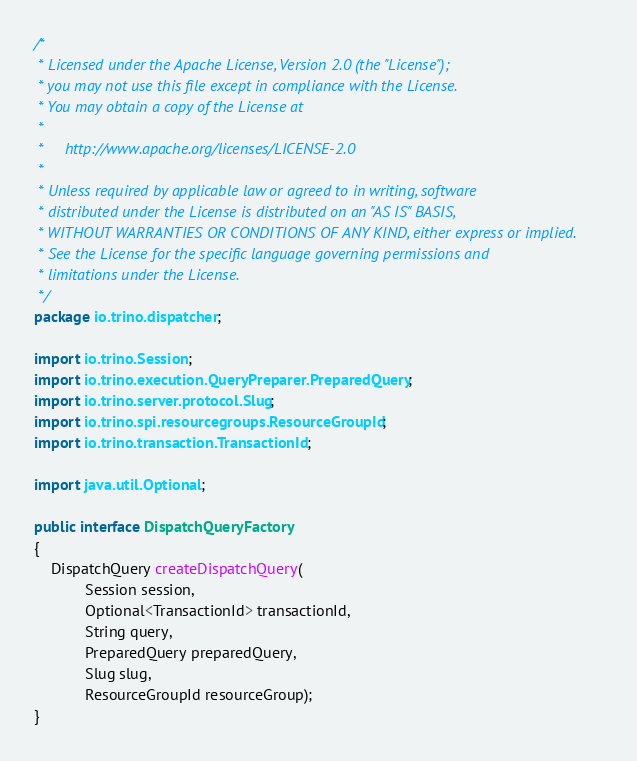<code> <loc_0><loc_0><loc_500><loc_500><_Java_>/*
 * Licensed under the Apache License, Version 2.0 (the "License");
 * you may not use this file except in compliance with the License.
 * You may obtain a copy of the License at
 *
 *     http://www.apache.org/licenses/LICENSE-2.0
 *
 * Unless required by applicable law or agreed to in writing, software
 * distributed under the License is distributed on an "AS IS" BASIS,
 * WITHOUT WARRANTIES OR CONDITIONS OF ANY KIND, either express or implied.
 * See the License for the specific language governing permissions and
 * limitations under the License.
 */
package io.trino.dispatcher;

import io.trino.Session;
import io.trino.execution.QueryPreparer.PreparedQuery;
import io.trino.server.protocol.Slug;
import io.trino.spi.resourcegroups.ResourceGroupId;
import io.trino.transaction.TransactionId;

import java.util.Optional;

public interface DispatchQueryFactory
{
    DispatchQuery createDispatchQuery(
            Session session,
            Optional<TransactionId> transactionId,
            String query,
            PreparedQuery preparedQuery,
            Slug slug,
            ResourceGroupId resourceGroup);
}
</code> 